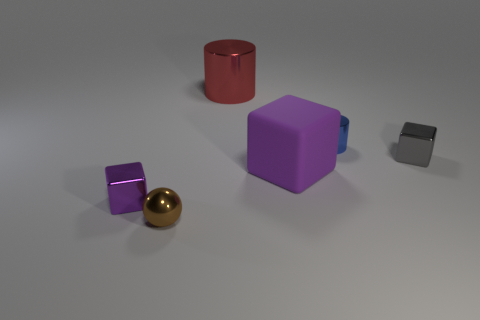There is a small cylinder; what number of tiny metallic blocks are left of it?
Your answer should be very brief. 1. The small cube that is to the right of the shiny block in front of the gray thing is what color?
Offer a terse response. Gray. Is there any other thing that has the same shape as the brown metal thing?
Your answer should be very brief. No. Are there an equal number of shiny balls to the right of the large rubber object and big purple rubber cubes right of the tiny blue shiny thing?
Offer a terse response. Yes. How many cubes are brown objects or big red things?
Provide a short and direct response. 0. What number of other objects are there of the same material as the gray cube?
Your response must be concise. 4. What is the shape of the purple object to the right of the large red shiny object?
Ensure brevity in your answer.  Cube. What is the material of the purple block that is left of the purple block on the right side of the tiny purple cube?
Offer a terse response. Metal. Are there more small things that are on the right side of the blue shiny cylinder than large blue shiny spheres?
Your answer should be very brief. Yes. What number of other objects are there of the same color as the ball?
Provide a succinct answer. 0. 